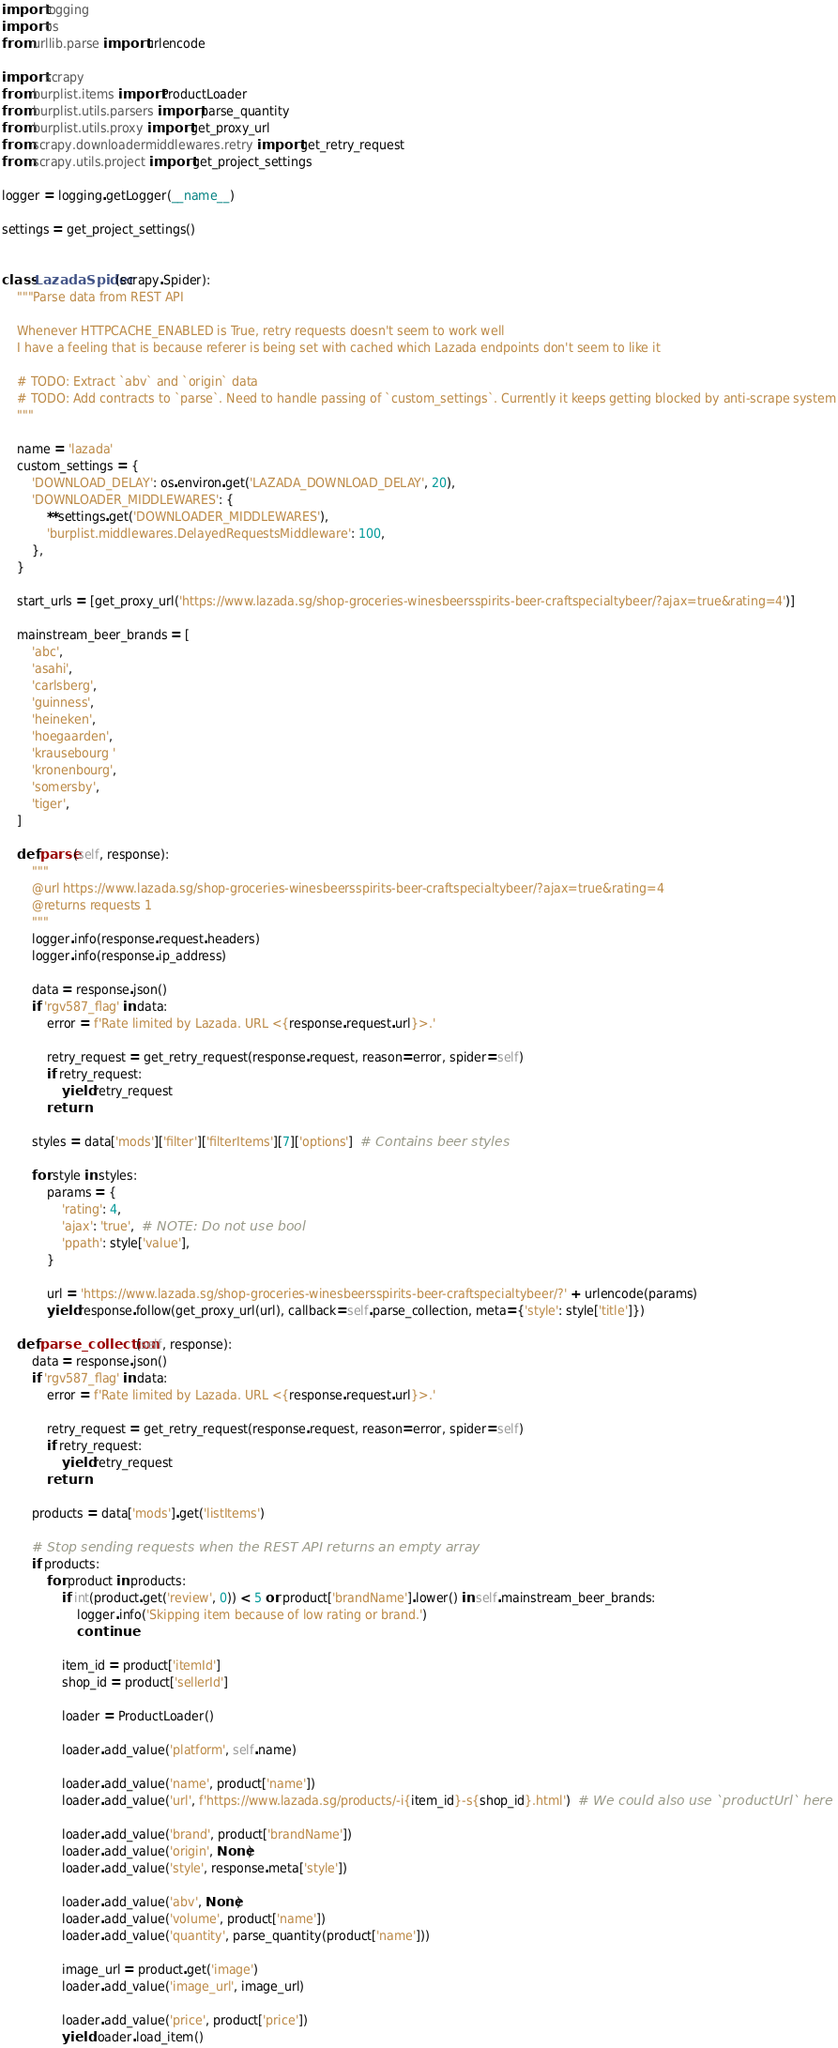Convert code to text. <code><loc_0><loc_0><loc_500><loc_500><_Python_>import logging
import os
from urllib.parse import urlencode

import scrapy
from burplist.items import ProductLoader
from burplist.utils.parsers import parse_quantity
from burplist.utils.proxy import get_proxy_url
from scrapy.downloadermiddlewares.retry import get_retry_request
from scrapy.utils.project import get_project_settings

logger = logging.getLogger(__name__)

settings = get_project_settings()


class LazadaSpider(scrapy.Spider):
    """Parse data from REST API

    Whenever HTTPCACHE_ENABLED is True, retry requests doesn't seem to work well
    I have a feeling that is because referer is being set with cached which Lazada endpoints don't seem to like it

    # TODO: Extract `abv` and `origin` data
    # TODO: Add contracts to `parse`. Need to handle passing of `custom_settings`. Currently it keeps getting blocked by anti-scrape system
    """

    name = 'lazada'
    custom_settings = {
        'DOWNLOAD_DELAY': os.environ.get('LAZADA_DOWNLOAD_DELAY', 20),
        'DOWNLOADER_MIDDLEWARES': {
            **settings.get('DOWNLOADER_MIDDLEWARES'),
            'burplist.middlewares.DelayedRequestsMiddleware': 100,
        },
    }

    start_urls = [get_proxy_url('https://www.lazada.sg/shop-groceries-winesbeersspirits-beer-craftspecialtybeer/?ajax=true&rating=4')]

    mainstream_beer_brands = [
        'abc',
        'asahi',
        'carlsberg',
        'guinness',
        'heineken',
        'hoegaarden',
        'krausebourg '
        'kronenbourg',
        'somersby',
        'tiger',
    ]

    def parse(self, response):
        """
        @url https://www.lazada.sg/shop-groceries-winesbeersspirits-beer-craftspecialtybeer/?ajax=true&rating=4
        @returns requests 1
        """
        logger.info(response.request.headers)
        logger.info(response.ip_address)

        data = response.json()
        if 'rgv587_flag' in data:
            error = f'Rate limited by Lazada. URL <{response.request.url}>.'

            retry_request = get_retry_request(response.request, reason=error, spider=self)
            if retry_request:
                yield retry_request
            return

        styles = data['mods']['filter']['filterItems'][7]['options']  # Contains beer styles

        for style in styles:
            params = {
                'rating': 4,
                'ajax': 'true',  # NOTE: Do not use bool
                'ppath': style['value'],
            }

            url = 'https://www.lazada.sg/shop-groceries-winesbeersspirits-beer-craftspecialtybeer/?' + urlencode(params)
            yield response.follow(get_proxy_url(url), callback=self.parse_collection, meta={'style': style['title']})

    def parse_collection(self, response):
        data = response.json()
        if 'rgv587_flag' in data:
            error = f'Rate limited by Lazada. URL <{response.request.url}>.'

            retry_request = get_retry_request(response.request, reason=error, spider=self)
            if retry_request:
                yield retry_request
            return

        products = data['mods'].get('listItems')

        # Stop sending requests when the REST API returns an empty array
        if products:
            for product in products:
                if int(product.get('review', 0)) < 5 or product['brandName'].lower() in self.mainstream_beer_brands:
                    logger.info('Skipping item because of low rating or brand.')
                    continue

                item_id = product['itemId']
                shop_id = product['sellerId']

                loader = ProductLoader()

                loader.add_value('platform', self.name)

                loader.add_value('name', product['name'])
                loader.add_value('url', f'https://www.lazada.sg/products/-i{item_id}-s{shop_id}.html')  # We could also use `productUrl` here

                loader.add_value('brand', product['brandName'])
                loader.add_value('origin', None)
                loader.add_value('style', response.meta['style'])

                loader.add_value('abv', None)
                loader.add_value('volume', product['name'])
                loader.add_value('quantity', parse_quantity(product['name']))

                image_url = product.get('image')
                loader.add_value('image_url', image_url)

                loader.add_value('price', product['price'])
                yield loader.load_item()
</code> 